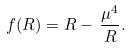Convert formula to latex. <formula><loc_0><loc_0><loc_500><loc_500>f ( R ) = R - \, \frac { \mu ^ { 4 } } { R } .</formula> 